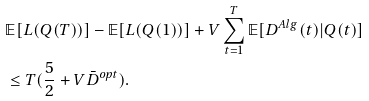Convert formula to latex. <formula><loc_0><loc_0><loc_500><loc_500>& \mathbb { E } [ L ( Q ( T ) ) ] - \mathbb { E } [ L ( Q ( 1 ) ) ] + V \sum _ { t = 1 } ^ { T } \mathbb { E } [ D ^ { A l g } ( t ) | Q ( t ) ] \\ & \leq T ( \frac { 5 } { 2 } + V \bar { D } ^ { o p t } ) .</formula> 